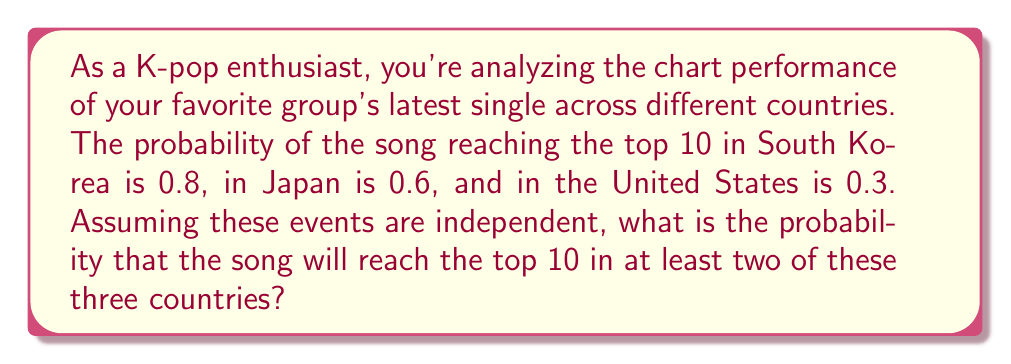Can you solve this math problem? Let's approach this step-by-step:

1) First, let's define our events:
   A: Top 10 in South Korea (P(A) = 0.8)
   B: Top 10 in Japan (P(B) = 0.6)
   C: Top 10 in the United States (P(C) = 0.3)

2) We want the probability of the song reaching the top 10 in at least two countries. It's easier to calculate the complement of this event (not reaching top 10 in at least two countries) and then subtract from 1.

3) The complement consists of three scenarios:
   - The song doesn't reach top 10 in any country
   - The song reaches top 10 in only South Korea
   - The song reaches top 10 in only Japan
   - The song reaches top 10 in only the United States

4) Let's calculate each:
   P(none) = (1-0.8) * (1-0.6) * (1-0.3) = 0.2 * 0.4 * 0.7 = 0.056
   P(only SK) = 0.8 * (1-0.6) * (1-0.3) = 0.8 * 0.4 * 0.7 = 0.224
   P(only Japan) = (1-0.8) * 0.6 * (1-0.3) = 0.2 * 0.6 * 0.7 = 0.084
   P(only US) = (1-0.8) * (1-0.6) * 0.3 = 0.2 * 0.4 * 0.3 = 0.024

5) The probability of the complement is the sum of these:
   P(complement) = 0.056 + 0.224 + 0.084 + 0.024 = 0.388

6) Therefore, the probability of reaching top 10 in at least two countries is:
   P(at least two) = 1 - P(complement) = 1 - 0.388 = 0.612
Answer: 0.612 